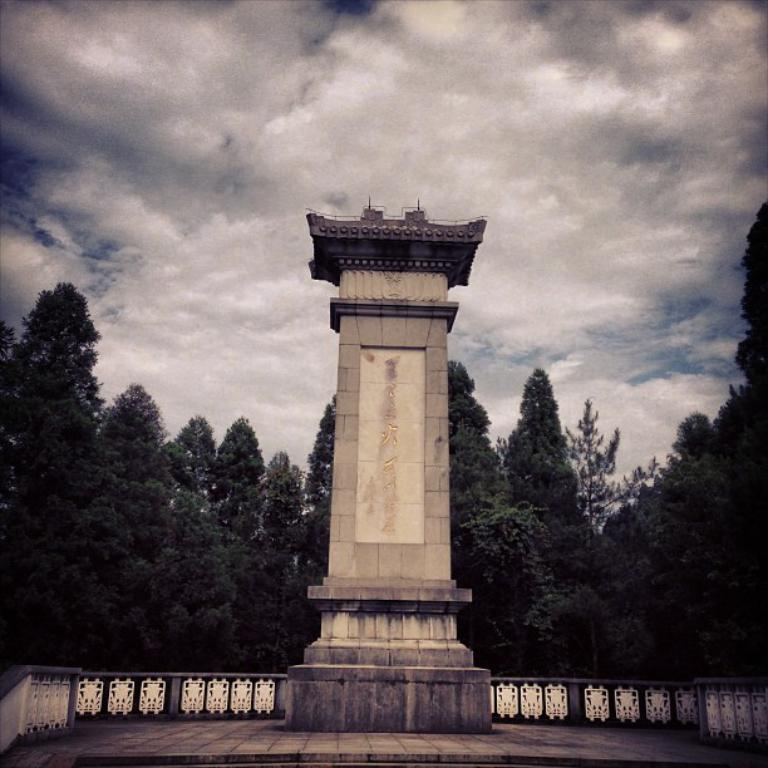What is the main structure in the center of the image? There is a tower in the center of the image. What can be seen in the background of the image? There are trees in the background of the image. What is located in the center of the image besides the tower? There is a fence in the center of the image. How would you describe the sky in the image? The sky is cloudy in the image. What type of cracker is being used to pay off the debt in the image? There is no cracker or debt present in the image. 